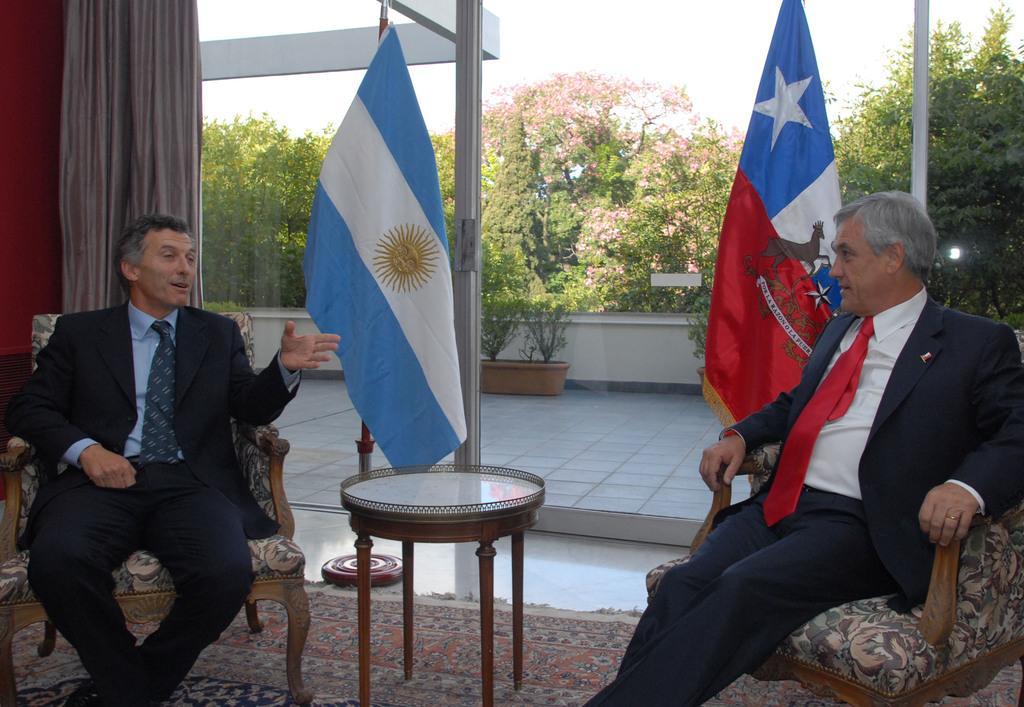How would you summarize this image in a sentence or two? In this picture we can see two men wore blazer, tie sitting on chairs and talking to each other and in front of them there is table, flags and in background we can see trees, flower pot, sky, curtains. 